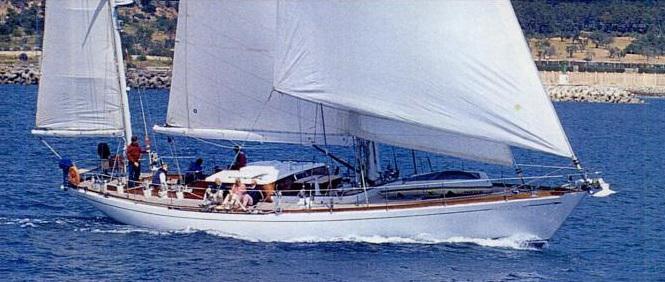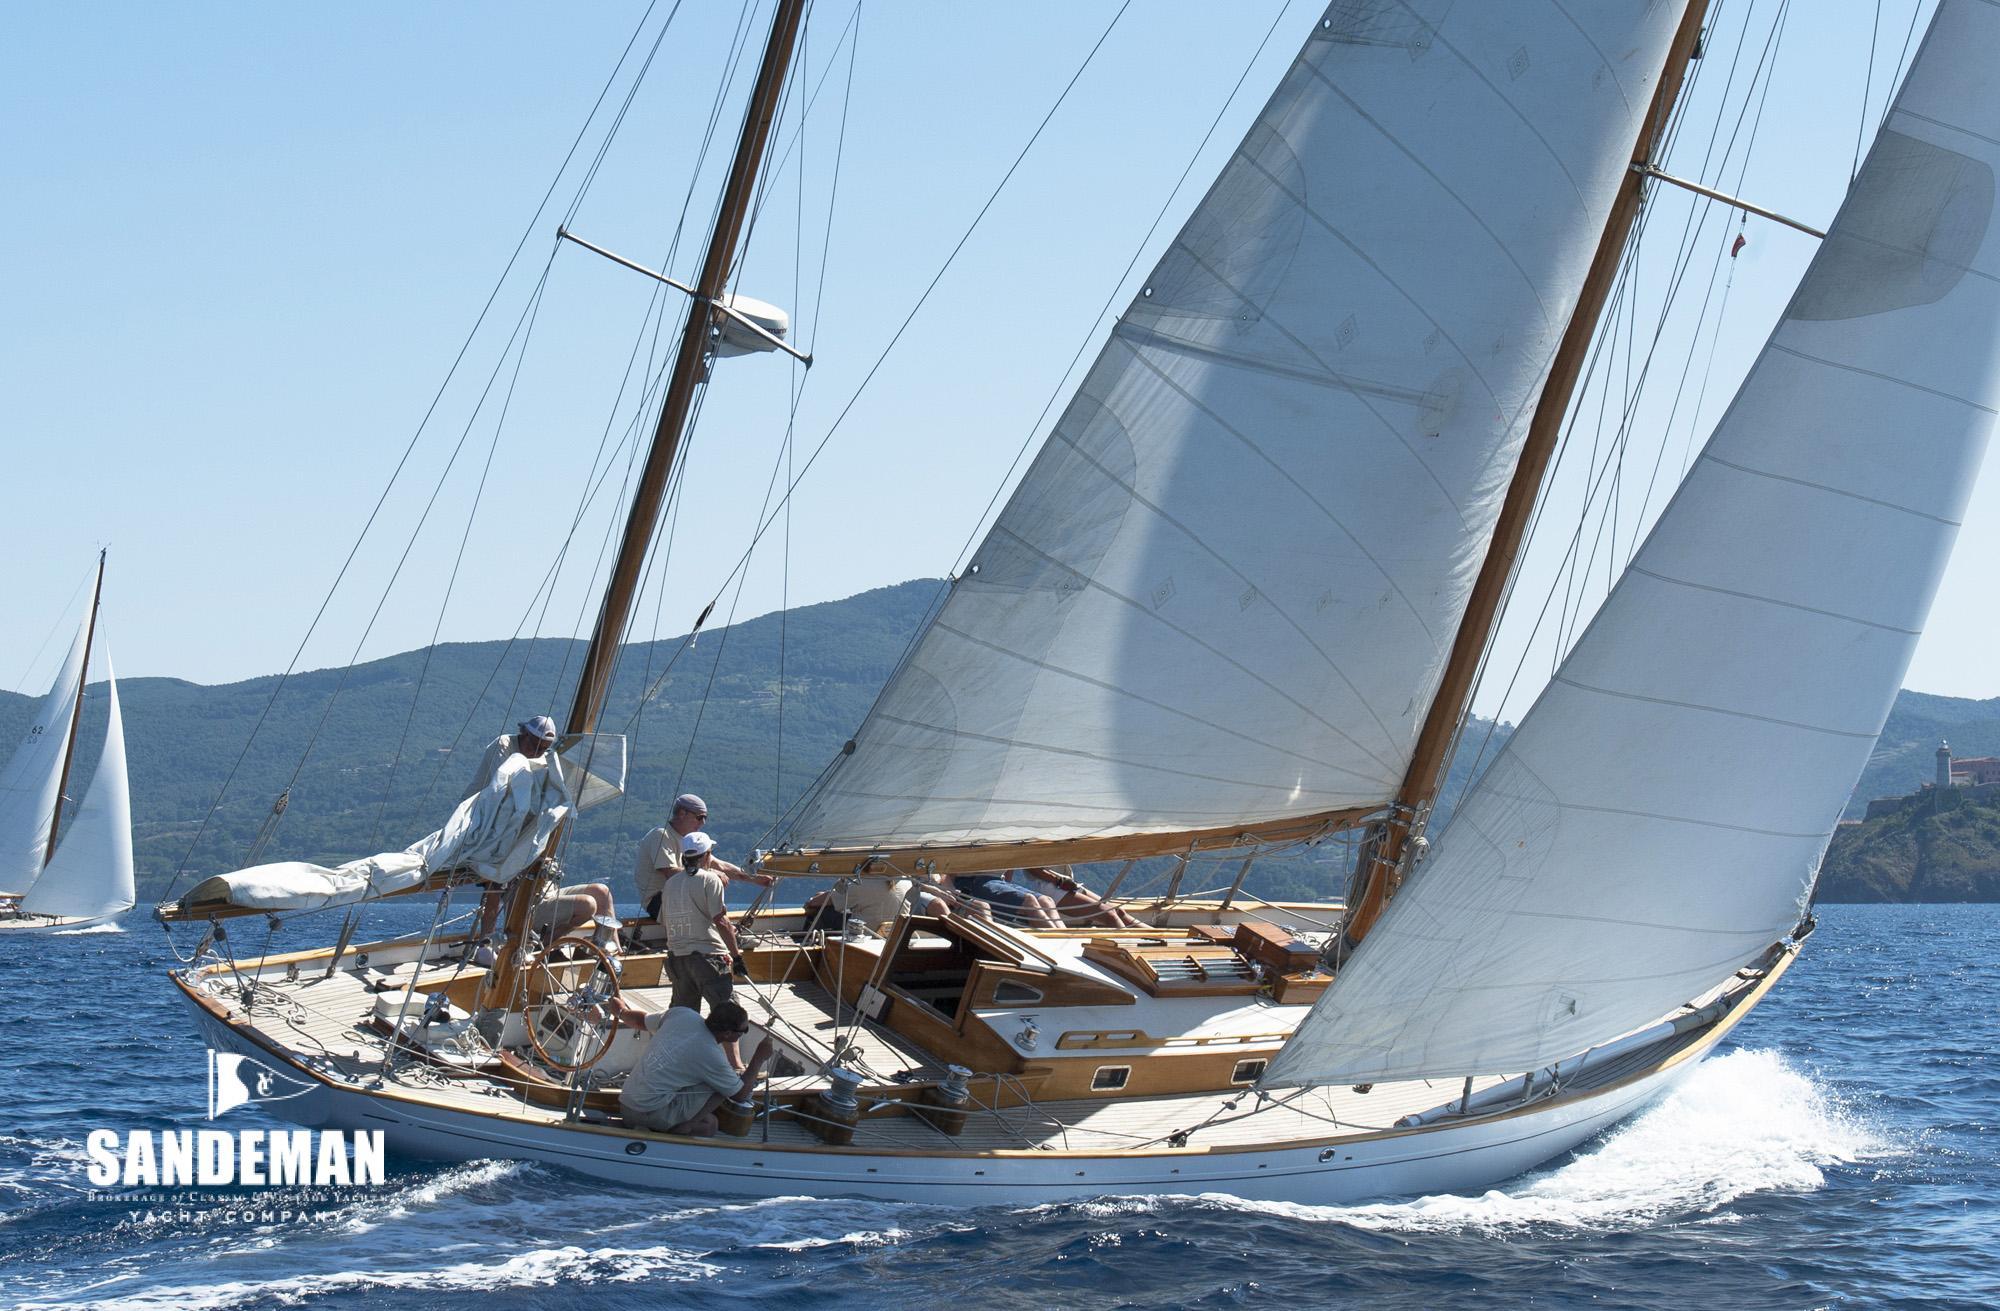The first image is the image on the left, the second image is the image on the right. For the images shown, is this caption "The left and right image contains the same number of sailboats with one with no sails out." true? Answer yes or no. No. The first image is the image on the left, the second image is the image on the right. Considering the images on both sides, is "One boat contains multiple people and creates white spray as it moves through water with unfurled sails, while the other boat is still and has furled sails." valid? Answer yes or no. No. 